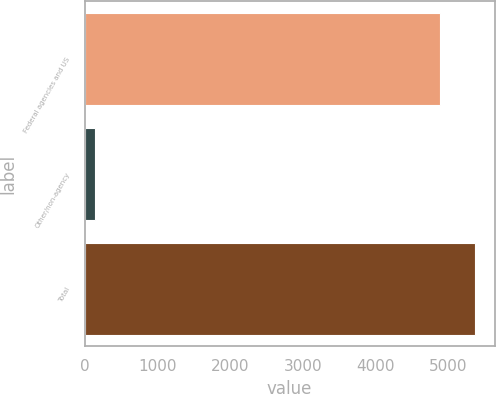<chart> <loc_0><loc_0><loc_500><loc_500><bar_chart><fcel>Federal agencies and US<fcel>Other/non-agency<fcel>Total<nl><fcel>4881<fcel>139<fcel>5369.1<nl></chart> 